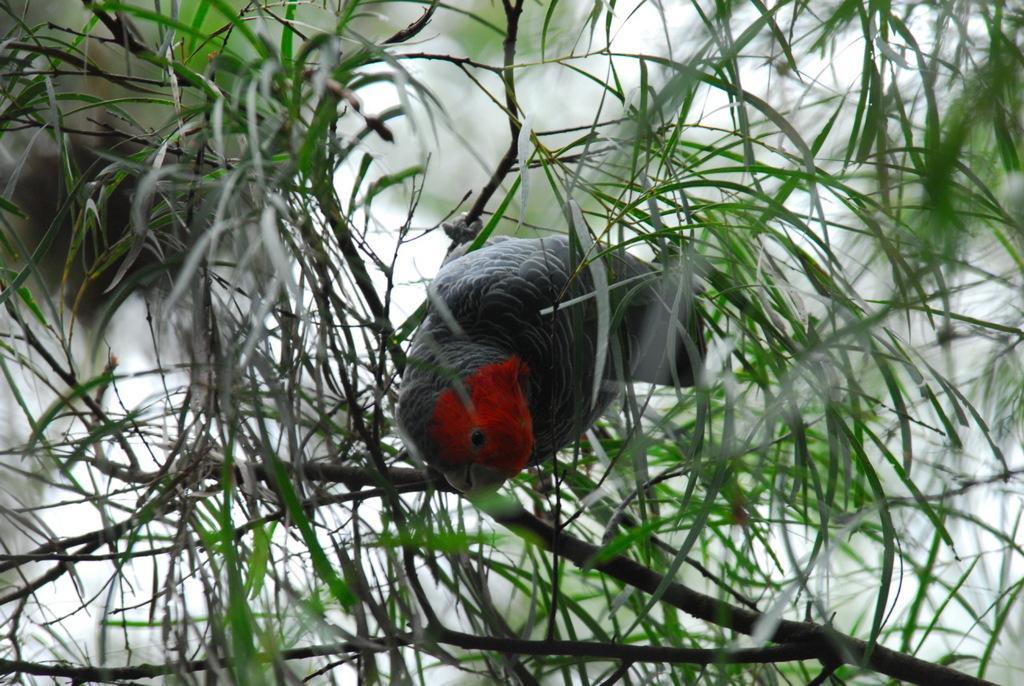How would you summarize this image in a sentence or two? In this image, we can see a bird on a plant. We can also see some green leaves. 